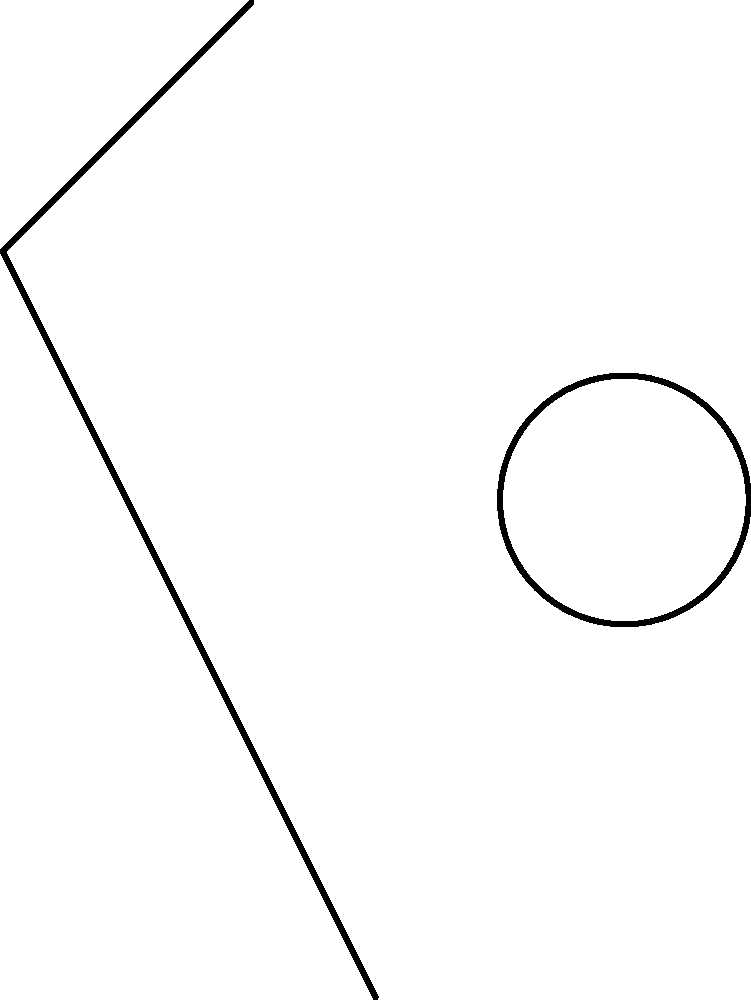In proper tackling form, which part of the body should initiate the contact with the target, and what is the primary source of power for driving through the tackle? To understand proper tackling form in football, we need to consider the biomechanics involved:

1. Initial position: The tackler should have a low center of gravity with knees bent and feet shoulder-width apart.

2. Head position: The head should be up, with the chin tucked to protect the neck. This is crucial for safety and maintaining visual contact with the target.

3. Contact point: The initial contact should be made with the shoulder, not the head. This is safer for the tackler and more effective for stopping the ball carrier.

4. Arm position: The arms should wrap around the target immediately after shoulder contact to secure the tackle.

5. Power source: The primary source of power comes from the legs. The tackler should drive upward and forward through the target using leg strength.

6. Follow-through: After initial contact, the tackler should continue to drive their legs, pushing through the target to complete the tackle.

In the diagram, we can see:
- The red arrow represents the force vector of the tackle, initiating from the shoulder area towards the target.
- The blue arrow represents the leg drive, which provides the power to complete the tackle.

The shoulder initiates contact for safety and effectiveness, while the legs provide the driving force to complete the tackle successfully.
Answer: Shoulder initiates contact; legs provide power. 